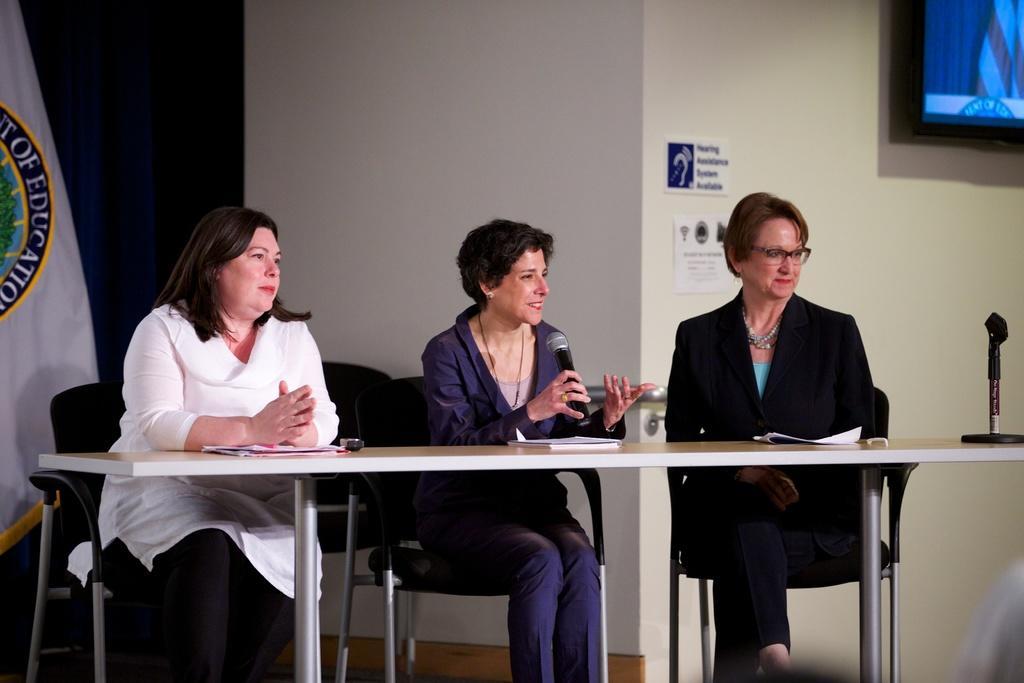How would you summarize this image in a sentence or two? In this image I see 3 women and 3 of them are sitting on chairs and there is a table in front of them on which there are books, papers and this woman is holding a mic and I can also see that this 3 are smiling, In the background I see few chairs, a flag, wall on which there are 2 papers and a TV screen over here. 